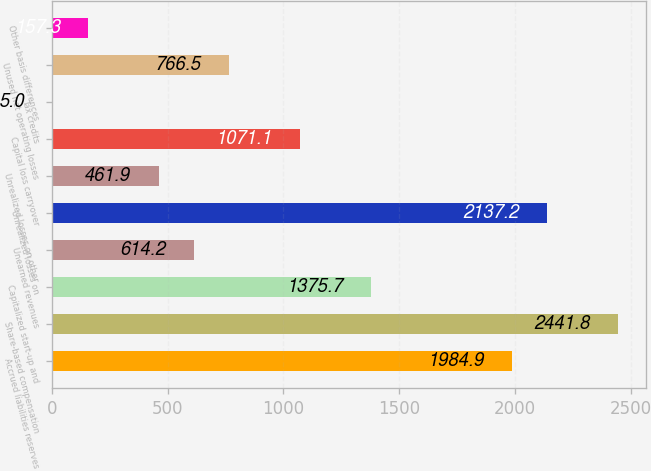Convert chart to OTSL. <chart><loc_0><loc_0><loc_500><loc_500><bar_chart><fcel>Accrued liabilities reserves<fcel>Share-based compensation<fcel>Capitalized start-up and<fcel>Unearned revenues<fcel>Unrealized losses on<fcel>Unrealized losses on other<fcel>Capital loss carryover<fcel>Tax credits<fcel>Unused net operating losses<fcel>Other basis differences<nl><fcel>1984.9<fcel>2441.8<fcel>1375.7<fcel>614.2<fcel>2137.2<fcel>461.9<fcel>1071.1<fcel>5<fcel>766.5<fcel>157.3<nl></chart> 